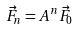Convert formula to latex. <formula><loc_0><loc_0><loc_500><loc_500>\vec { F } _ { n } = A ^ { n } \vec { F } _ { 0 }</formula> 